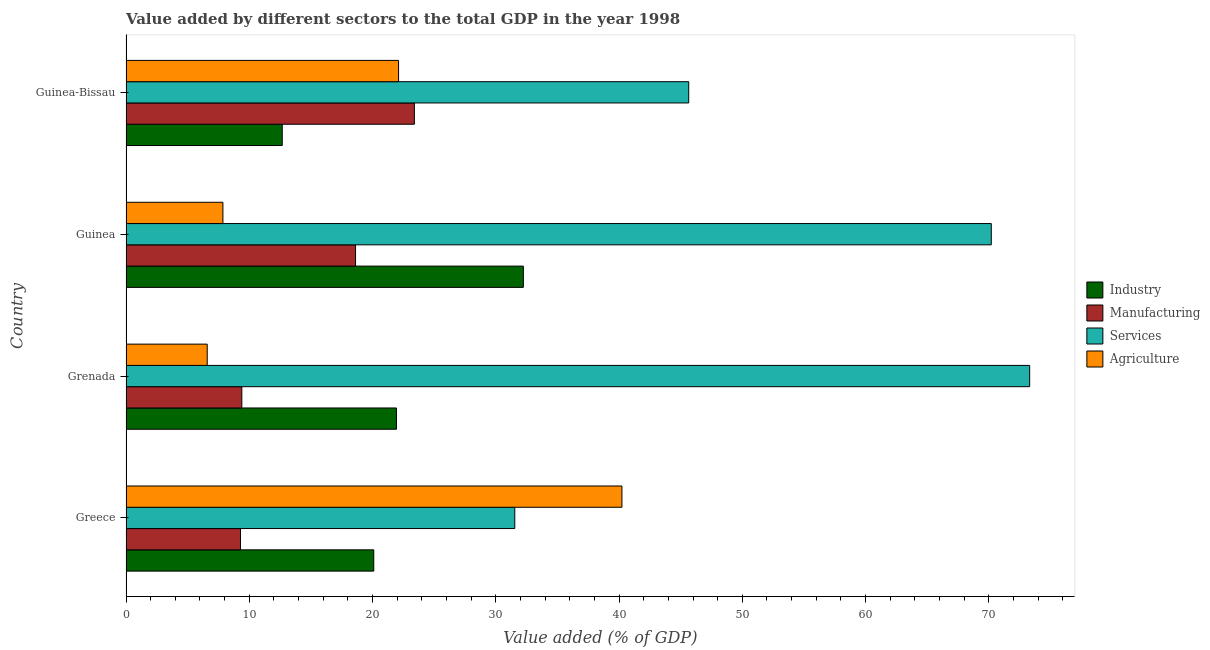How many different coloured bars are there?
Make the answer very short. 4. How many groups of bars are there?
Make the answer very short. 4. Are the number of bars on each tick of the Y-axis equal?
Provide a short and direct response. Yes. What is the value added by agricultural sector in Guinea?
Provide a succinct answer. 7.86. Across all countries, what is the maximum value added by agricultural sector?
Give a very brief answer. 40.23. Across all countries, what is the minimum value added by agricultural sector?
Ensure brevity in your answer.  6.59. In which country was the value added by agricultural sector maximum?
Keep it short and to the point. Greece. In which country was the value added by manufacturing sector minimum?
Make the answer very short. Greece. What is the total value added by services sector in the graph?
Your response must be concise. 220.7. What is the difference between the value added by manufacturing sector in Guinea and that in Guinea-Bissau?
Keep it short and to the point. -4.77. What is the difference between the value added by services sector in Grenada and the value added by industrial sector in Guinea?
Keep it short and to the point. 41.08. What is the average value added by agricultural sector per country?
Offer a very short reply. 19.2. What is the difference between the value added by manufacturing sector and value added by industrial sector in Grenada?
Keep it short and to the point. -12.54. What is the ratio of the value added by services sector in Grenada to that in Guinea?
Provide a succinct answer. 1.04. Is the value added by industrial sector in Guinea less than that in Guinea-Bissau?
Make the answer very short. No. What is the difference between the highest and the second highest value added by agricultural sector?
Give a very brief answer. 18.12. What is the difference between the highest and the lowest value added by services sector?
Offer a terse response. 41.77. What does the 1st bar from the top in Greece represents?
Keep it short and to the point. Agriculture. What does the 1st bar from the bottom in Grenada represents?
Your response must be concise. Industry. Is it the case that in every country, the sum of the value added by industrial sector and value added by manufacturing sector is greater than the value added by services sector?
Ensure brevity in your answer.  No. Are all the bars in the graph horizontal?
Your answer should be very brief. Yes. What is the difference between two consecutive major ticks on the X-axis?
Give a very brief answer. 10. Are the values on the major ticks of X-axis written in scientific E-notation?
Offer a terse response. No. Does the graph contain grids?
Provide a short and direct response. No. How many legend labels are there?
Give a very brief answer. 4. What is the title of the graph?
Provide a succinct answer. Value added by different sectors to the total GDP in the year 1998. What is the label or title of the X-axis?
Give a very brief answer. Value added (% of GDP). What is the Value added (% of GDP) in Industry in Greece?
Offer a very short reply. 20.1. What is the Value added (% of GDP) of Manufacturing in Greece?
Offer a terse response. 9.29. What is the Value added (% of GDP) in Services in Greece?
Make the answer very short. 31.54. What is the Value added (% of GDP) in Agriculture in Greece?
Your answer should be very brief. 40.23. What is the Value added (% of GDP) of Industry in Grenada?
Offer a terse response. 21.94. What is the Value added (% of GDP) in Manufacturing in Grenada?
Make the answer very short. 9.4. What is the Value added (% of GDP) in Services in Grenada?
Offer a terse response. 73.31. What is the Value added (% of GDP) of Agriculture in Grenada?
Make the answer very short. 6.59. What is the Value added (% of GDP) of Industry in Guinea?
Provide a short and direct response. 32.24. What is the Value added (% of GDP) of Manufacturing in Guinea?
Your answer should be very brief. 18.62. What is the Value added (% of GDP) of Services in Guinea?
Your answer should be very brief. 70.2. What is the Value added (% of GDP) in Agriculture in Guinea?
Ensure brevity in your answer.  7.86. What is the Value added (% of GDP) in Industry in Guinea-Bissau?
Make the answer very short. 12.68. What is the Value added (% of GDP) in Manufacturing in Guinea-Bissau?
Give a very brief answer. 23.39. What is the Value added (% of GDP) of Services in Guinea-Bissau?
Your answer should be compact. 45.65. What is the Value added (% of GDP) in Agriculture in Guinea-Bissau?
Your answer should be compact. 22.11. Across all countries, what is the maximum Value added (% of GDP) of Industry?
Make the answer very short. 32.24. Across all countries, what is the maximum Value added (% of GDP) of Manufacturing?
Provide a short and direct response. 23.39. Across all countries, what is the maximum Value added (% of GDP) in Services?
Your response must be concise. 73.31. Across all countries, what is the maximum Value added (% of GDP) in Agriculture?
Ensure brevity in your answer.  40.23. Across all countries, what is the minimum Value added (% of GDP) of Industry?
Ensure brevity in your answer.  12.68. Across all countries, what is the minimum Value added (% of GDP) of Manufacturing?
Your answer should be very brief. 9.29. Across all countries, what is the minimum Value added (% of GDP) of Services?
Keep it short and to the point. 31.54. Across all countries, what is the minimum Value added (% of GDP) of Agriculture?
Make the answer very short. 6.59. What is the total Value added (% of GDP) in Industry in the graph?
Your answer should be very brief. 86.95. What is the total Value added (% of GDP) of Manufacturing in the graph?
Provide a succinct answer. 60.7. What is the total Value added (% of GDP) in Services in the graph?
Provide a succinct answer. 220.7. What is the total Value added (% of GDP) of Agriculture in the graph?
Give a very brief answer. 76.79. What is the difference between the Value added (% of GDP) in Industry in Greece and that in Grenada?
Your answer should be compact. -1.84. What is the difference between the Value added (% of GDP) in Manufacturing in Greece and that in Grenada?
Your answer should be very brief. -0.11. What is the difference between the Value added (% of GDP) of Services in Greece and that in Grenada?
Your response must be concise. -41.77. What is the difference between the Value added (% of GDP) in Agriculture in Greece and that in Grenada?
Provide a short and direct response. 33.65. What is the difference between the Value added (% of GDP) in Industry in Greece and that in Guinea?
Your response must be concise. -12.14. What is the difference between the Value added (% of GDP) in Manufacturing in Greece and that in Guinea?
Make the answer very short. -9.34. What is the difference between the Value added (% of GDP) of Services in Greece and that in Guinea?
Provide a succinct answer. -38.66. What is the difference between the Value added (% of GDP) of Agriculture in Greece and that in Guinea?
Keep it short and to the point. 32.37. What is the difference between the Value added (% of GDP) in Industry in Greece and that in Guinea-Bissau?
Provide a short and direct response. 7.43. What is the difference between the Value added (% of GDP) of Manufacturing in Greece and that in Guinea-Bissau?
Your answer should be compact. -14.11. What is the difference between the Value added (% of GDP) of Services in Greece and that in Guinea-Bissau?
Make the answer very short. -14.11. What is the difference between the Value added (% of GDP) of Agriculture in Greece and that in Guinea-Bissau?
Your response must be concise. 18.12. What is the difference between the Value added (% of GDP) in Industry in Grenada and that in Guinea?
Make the answer very short. -10.29. What is the difference between the Value added (% of GDP) in Manufacturing in Grenada and that in Guinea?
Your response must be concise. -9.23. What is the difference between the Value added (% of GDP) of Services in Grenada and that in Guinea?
Provide a succinct answer. 3.11. What is the difference between the Value added (% of GDP) of Agriculture in Grenada and that in Guinea?
Ensure brevity in your answer.  -1.27. What is the difference between the Value added (% of GDP) in Industry in Grenada and that in Guinea-Bissau?
Offer a terse response. 9.27. What is the difference between the Value added (% of GDP) of Manufacturing in Grenada and that in Guinea-Bissau?
Keep it short and to the point. -14. What is the difference between the Value added (% of GDP) of Services in Grenada and that in Guinea-Bissau?
Ensure brevity in your answer.  27.66. What is the difference between the Value added (% of GDP) in Agriculture in Grenada and that in Guinea-Bissau?
Your answer should be very brief. -15.52. What is the difference between the Value added (% of GDP) in Industry in Guinea and that in Guinea-Bissau?
Offer a very short reply. 19.56. What is the difference between the Value added (% of GDP) in Manufacturing in Guinea and that in Guinea-Bissau?
Keep it short and to the point. -4.77. What is the difference between the Value added (% of GDP) of Services in Guinea and that in Guinea-Bissau?
Provide a short and direct response. 24.55. What is the difference between the Value added (% of GDP) in Agriculture in Guinea and that in Guinea-Bissau?
Offer a terse response. -14.25. What is the difference between the Value added (% of GDP) of Industry in Greece and the Value added (% of GDP) of Manufacturing in Grenada?
Give a very brief answer. 10.7. What is the difference between the Value added (% of GDP) in Industry in Greece and the Value added (% of GDP) in Services in Grenada?
Offer a terse response. -53.21. What is the difference between the Value added (% of GDP) in Industry in Greece and the Value added (% of GDP) in Agriculture in Grenada?
Provide a succinct answer. 13.51. What is the difference between the Value added (% of GDP) of Manufacturing in Greece and the Value added (% of GDP) of Services in Grenada?
Provide a succinct answer. -64.03. What is the difference between the Value added (% of GDP) in Manufacturing in Greece and the Value added (% of GDP) in Agriculture in Grenada?
Give a very brief answer. 2.7. What is the difference between the Value added (% of GDP) in Services in Greece and the Value added (% of GDP) in Agriculture in Grenada?
Make the answer very short. 24.95. What is the difference between the Value added (% of GDP) of Industry in Greece and the Value added (% of GDP) of Manufacturing in Guinea?
Make the answer very short. 1.48. What is the difference between the Value added (% of GDP) of Industry in Greece and the Value added (% of GDP) of Services in Guinea?
Your answer should be compact. -50.1. What is the difference between the Value added (% of GDP) of Industry in Greece and the Value added (% of GDP) of Agriculture in Guinea?
Your answer should be very brief. 12.24. What is the difference between the Value added (% of GDP) of Manufacturing in Greece and the Value added (% of GDP) of Services in Guinea?
Provide a succinct answer. -60.91. What is the difference between the Value added (% of GDP) of Manufacturing in Greece and the Value added (% of GDP) of Agriculture in Guinea?
Offer a very short reply. 1.43. What is the difference between the Value added (% of GDP) of Services in Greece and the Value added (% of GDP) of Agriculture in Guinea?
Give a very brief answer. 23.68. What is the difference between the Value added (% of GDP) in Industry in Greece and the Value added (% of GDP) in Manufacturing in Guinea-Bissau?
Make the answer very short. -3.29. What is the difference between the Value added (% of GDP) of Industry in Greece and the Value added (% of GDP) of Services in Guinea-Bissau?
Your answer should be compact. -25.55. What is the difference between the Value added (% of GDP) in Industry in Greece and the Value added (% of GDP) in Agriculture in Guinea-Bissau?
Offer a terse response. -2.01. What is the difference between the Value added (% of GDP) in Manufacturing in Greece and the Value added (% of GDP) in Services in Guinea-Bissau?
Your answer should be very brief. -36.36. What is the difference between the Value added (% of GDP) of Manufacturing in Greece and the Value added (% of GDP) of Agriculture in Guinea-Bissau?
Provide a succinct answer. -12.83. What is the difference between the Value added (% of GDP) of Services in Greece and the Value added (% of GDP) of Agriculture in Guinea-Bissau?
Give a very brief answer. 9.43. What is the difference between the Value added (% of GDP) of Industry in Grenada and the Value added (% of GDP) of Manufacturing in Guinea?
Ensure brevity in your answer.  3.32. What is the difference between the Value added (% of GDP) of Industry in Grenada and the Value added (% of GDP) of Services in Guinea?
Your answer should be very brief. -48.26. What is the difference between the Value added (% of GDP) of Industry in Grenada and the Value added (% of GDP) of Agriculture in Guinea?
Your answer should be very brief. 14.08. What is the difference between the Value added (% of GDP) in Manufacturing in Grenada and the Value added (% of GDP) in Services in Guinea?
Provide a succinct answer. -60.8. What is the difference between the Value added (% of GDP) in Manufacturing in Grenada and the Value added (% of GDP) in Agriculture in Guinea?
Give a very brief answer. 1.54. What is the difference between the Value added (% of GDP) in Services in Grenada and the Value added (% of GDP) in Agriculture in Guinea?
Keep it short and to the point. 65.45. What is the difference between the Value added (% of GDP) of Industry in Grenada and the Value added (% of GDP) of Manufacturing in Guinea-Bissau?
Keep it short and to the point. -1.45. What is the difference between the Value added (% of GDP) in Industry in Grenada and the Value added (% of GDP) in Services in Guinea-Bissau?
Offer a very short reply. -23.71. What is the difference between the Value added (% of GDP) of Industry in Grenada and the Value added (% of GDP) of Agriculture in Guinea-Bissau?
Provide a succinct answer. -0.17. What is the difference between the Value added (% of GDP) in Manufacturing in Grenada and the Value added (% of GDP) in Services in Guinea-Bissau?
Your response must be concise. -36.26. What is the difference between the Value added (% of GDP) in Manufacturing in Grenada and the Value added (% of GDP) in Agriculture in Guinea-Bissau?
Ensure brevity in your answer.  -12.72. What is the difference between the Value added (% of GDP) of Services in Grenada and the Value added (% of GDP) of Agriculture in Guinea-Bissau?
Your answer should be compact. 51.2. What is the difference between the Value added (% of GDP) in Industry in Guinea and the Value added (% of GDP) in Manufacturing in Guinea-Bissau?
Offer a very short reply. 8.84. What is the difference between the Value added (% of GDP) of Industry in Guinea and the Value added (% of GDP) of Services in Guinea-Bissau?
Offer a terse response. -13.42. What is the difference between the Value added (% of GDP) of Industry in Guinea and the Value added (% of GDP) of Agriculture in Guinea-Bissau?
Your answer should be very brief. 10.12. What is the difference between the Value added (% of GDP) in Manufacturing in Guinea and the Value added (% of GDP) in Services in Guinea-Bissau?
Provide a short and direct response. -27.03. What is the difference between the Value added (% of GDP) of Manufacturing in Guinea and the Value added (% of GDP) of Agriculture in Guinea-Bissau?
Give a very brief answer. -3.49. What is the difference between the Value added (% of GDP) of Services in Guinea and the Value added (% of GDP) of Agriculture in Guinea-Bissau?
Your answer should be compact. 48.09. What is the average Value added (% of GDP) in Industry per country?
Keep it short and to the point. 21.74. What is the average Value added (% of GDP) of Manufacturing per country?
Provide a short and direct response. 15.17. What is the average Value added (% of GDP) in Services per country?
Your answer should be very brief. 55.18. What is the average Value added (% of GDP) of Agriculture per country?
Your response must be concise. 19.2. What is the difference between the Value added (% of GDP) in Industry and Value added (% of GDP) in Manufacturing in Greece?
Provide a succinct answer. 10.81. What is the difference between the Value added (% of GDP) in Industry and Value added (% of GDP) in Services in Greece?
Provide a succinct answer. -11.44. What is the difference between the Value added (% of GDP) of Industry and Value added (% of GDP) of Agriculture in Greece?
Make the answer very short. -20.13. What is the difference between the Value added (% of GDP) in Manufacturing and Value added (% of GDP) in Services in Greece?
Keep it short and to the point. -22.25. What is the difference between the Value added (% of GDP) of Manufacturing and Value added (% of GDP) of Agriculture in Greece?
Provide a short and direct response. -30.95. What is the difference between the Value added (% of GDP) of Services and Value added (% of GDP) of Agriculture in Greece?
Your answer should be compact. -8.69. What is the difference between the Value added (% of GDP) in Industry and Value added (% of GDP) in Manufacturing in Grenada?
Your answer should be very brief. 12.55. What is the difference between the Value added (% of GDP) in Industry and Value added (% of GDP) in Services in Grenada?
Provide a short and direct response. -51.37. What is the difference between the Value added (% of GDP) of Industry and Value added (% of GDP) of Agriculture in Grenada?
Provide a succinct answer. 15.35. What is the difference between the Value added (% of GDP) of Manufacturing and Value added (% of GDP) of Services in Grenada?
Make the answer very short. -63.92. What is the difference between the Value added (% of GDP) in Manufacturing and Value added (% of GDP) in Agriculture in Grenada?
Ensure brevity in your answer.  2.81. What is the difference between the Value added (% of GDP) in Services and Value added (% of GDP) in Agriculture in Grenada?
Make the answer very short. 66.72. What is the difference between the Value added (% of GDP) in Industry and Value added (% of GDP) in Manufacturing in Guinea?
Offer a very short reply. 13.61. What is the difference between the Value added (% of GDP) in Industry and Value added (% of GDP) in Services in Guinea?
Your answer should be compact. -37.96. What is the difference between the Value added (% of GDP) in Industry and Value added (% of GDP) in Agriculture in Guinea?
Provide a succinct answer. 24.38. What is the difference between the Value added (% of GDP) of Manufacturing and Value added (% of GDP) of Services in Guinea?
Give a very brief answer. -51.58. What is the difference between the Value added (% of GDP) of Manufacturing and Value added (% of GDP) of Agriculture in Guinea?
Ensure brevity in your answer.  10.76. What is the difference between the Value added (% of GDP) in Services and Value added (% of GDP) in Agriculture in Guinea?
Provide a succinct answer. 62.34. What is the difference between the Value added (% of GDP) in Industry and Value added (% of GDP) in Manufacturing in Guinea-Bissau?
Offer a very short reply. -10.72. What is the difference between the Value added (% of GDP) in Industry and Value added (% of GDP) in Services in Guinea-Bissau?
Keep it short and to the point. -32.98. What is the difference between the Value added (% of GDP) of Industry and Value added (% of GDP) of Agriculture in Guinea-Bissau?
Offer a terse response. -9.44. What is the difference between the Value added (% of GDP) of Manufacturing and Value added (% of GDP) of Services in Guinea-Bissau?
Ensure brevity in your answer.  -22.26. What is the difference between the Value added (% of GDP) in Manufacturing and Value added (% of GDP) in Agriculture in Guinea-Bissau?
Provide a succinct answer. 1.28. What is the difference between the Value added (% of GDP) of Services and Value added (% of GDP) of Agriculture in Guinea-Bissau?
Your answer should be compact. 23.54. What is the ratio of the Value added (% of GDP) of Industry in Greece to that in Grenada?
Offer a very short reply. 0.92. What is the ratio of the Value added (% of GDP) of Manufacturing in Greece to that in Grenada?
Make the answer very short. 0.99. What is the ratio of the Value added (% of GDP) of Services in Greece to that in Grenada?
Offer a terse response. 0.43. What is the ratio of the Value added (% of GDP) in Agriculture in Greece to that in Grenada?
Your response must be concise. 6.11. What is the ratio of the Value added (% of GDP) in Industry in Greece to that in Guinea?
Make the answer very short. 0.62. What is the ratio of the Value added (% of GDP) in Manufacturing in Greece to that in Guinea?
Your answer should be very brief. 0.5. What is the ratio of the Value added (% of GDP) in Services in Greece to that in Guinea?
Give a very brief answer. 0.45. What is the ratio of the Value added (% of GDP) of Agriculture in Greece to that in Guinea?
Offer a very short reply. 5.12. What is the ratio of the Value added (% of GDP) of Industry in Greece to that in Guinea-Bissau?
Give a very brief answer. 1.59. What is the ratio of the Value added (% of GDP) in Manufacturing in Greece to that in Guinea-Bissau?
Your response must be concise. 0.4. What is the ratio of the Value added (% of GDP) in Services in Greece to that in Guinea-Bissau?
Provide a short and direct response. 0.69. What is the ratio of the Value added (% of GDP) in Agriculture in Greece to that in Guinea-Bissau?
Provide a succinct answer. 1.82. What is the ratio of the Value added (% of GDP) in Industry in Grenada to that in Guinea?
Provide a short and direct response. 0.68. What is the ratio of the Value added (% of GDP) in Manufacturing in Grenada to that in Guinea?
Provide a succinct answer. 0.5. What is the ratio of the Value added (% of GDP) in Services in Grenada to that in Guinea?
Provide a succinct answer. 1.04. What is the ratio of the Value added (% of GDP) in Agriculture in Grenada to that in Guinea?
Provide a succinct answer. 0.84. What is the ratio of the Value added (% of GDP) in Industry in Grenada to that in Guinea-Bissau?
Offer a terse response. 1.73. What is the ratio of the Value added (% of GDP) of Manufacturing in Grenada to that in Guinea-Bissau?
Your response must be concise. 0.4. What is the ratio of the Value added (% of GDP) of Services in Grenada to that in Guinea-Bissau?
Keep it short and to the point. 1.61. What is the ratio of the Value added (% of GDP) in Agriculture in Grenada to that in Guinea-Bissau?
Your answer should be very brief. 0.3. What is the ratio of the Value added (% of GDP) of Industry in Guinea to that in Guinea-Bissau?
Make the answer very short. 2.54. What is the ratio of the Value added (% of GDP) of Manufacturing in Guinea to that in Guinea-Bissau?
Provide a short and direct response. 0.8. What is the ratio of the Value added (% of GDP) in Services in Guinea to that in Guinea-Bissau?
Provide a short and direct response. 1.54. What is the ratio of the Value added (% of GDP) in Agriculture in Guinea to that in Guinea-Bissau?
Provide a succinct answer. 0.36. What is the difference between the highest and the second highest Value added (% of GDP) of Industry?
Provide a succinct answer. 10.29. What is the difference between the highest and the second highest Value added (% of GDP) of Manufacturing?
Offer a very short reply. 4.77. What is the difference between the highest and the second highest Value added (% of GDP) of Services?
Give a very brief answer. 3.11. What is the difference between the highest and the second highest Value added (% of GDP) of Agriculture?
Provide a short and direct response. 18.12. What is the difference between the highest and the lowest Value added (% of GDP) of Industry?
Ensure brevity in your answer.  19.56. What is the difference between the highest and the lowest Value added (% of GDP) in Manufacturing?
Offer a terse response. 14.11. What is the difference between the highest and the lowest Value added (% of GDP) of Services?
Make the answer very short. 41.77. What is the difference between the highest and the lowest Value added (% of GDP) in Agriculture?
Keep it short and to the point. 33.65. 